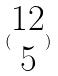Convert formula to latex. <formula><loc_0><loc_0><loc_500><loc_500>( \begin{matrix} 1 2 \\ 5 \end{matrix} )</formula> 